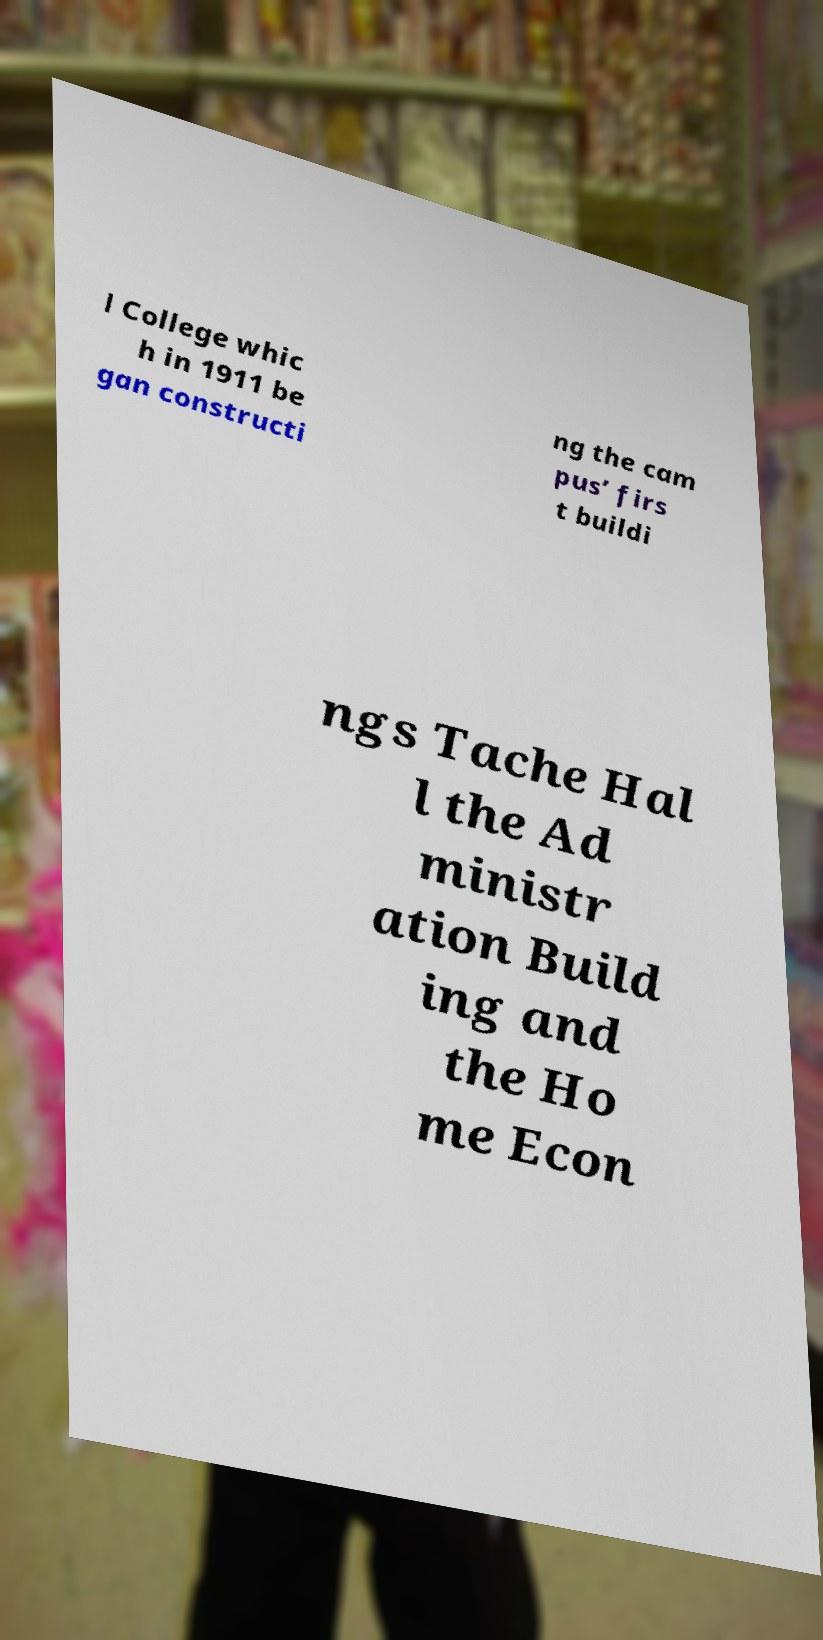Could you extract and type out the text from this image? l College whic h in 1911 be gan constructi ng the cam pus’ firs t buildi ngs Tache Hal l the Ad ministr ation Build ing and the Ho me Econ 